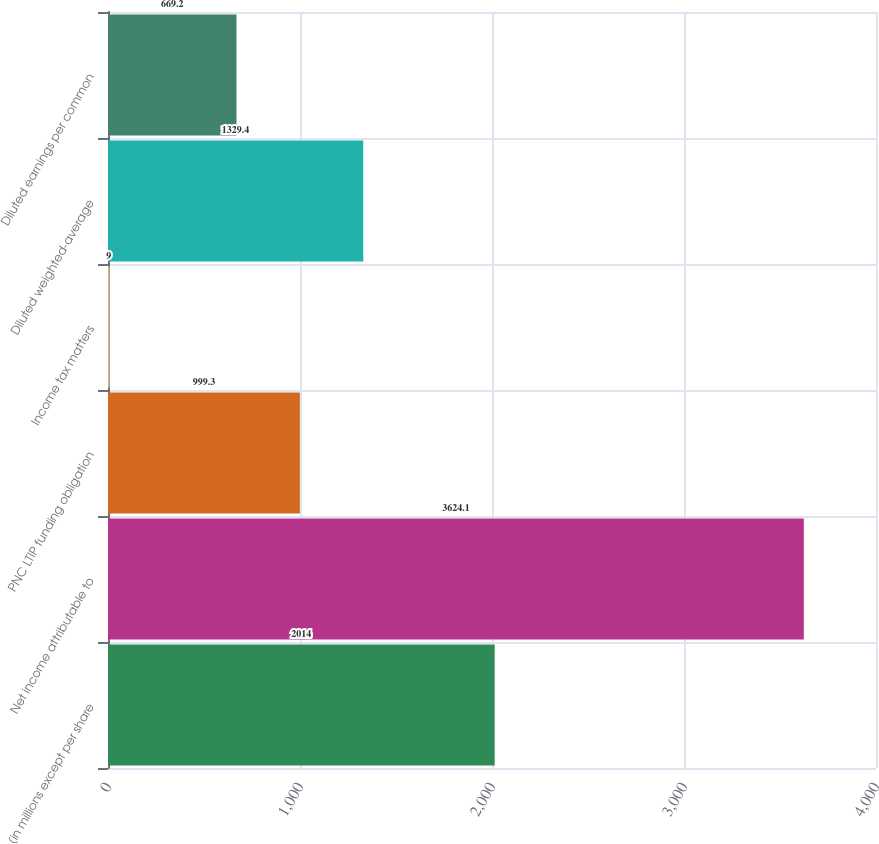Convert chart. <chart><loc_0><loc_0><loc_500><loc_500><bar_chart><fcel>(in millions except per share<fcel>Net income attributable to<fcel>PNC LTIP funding obligation<fcel>Income tax matters<fcel>Diluted weighted-average<fcel>Diluted earnings per common<nl><fcel>2014<fcel>3624.1<fcel>999.3<fcel>9<fcel>1329.4<fcel>669.2<nl></chart> 